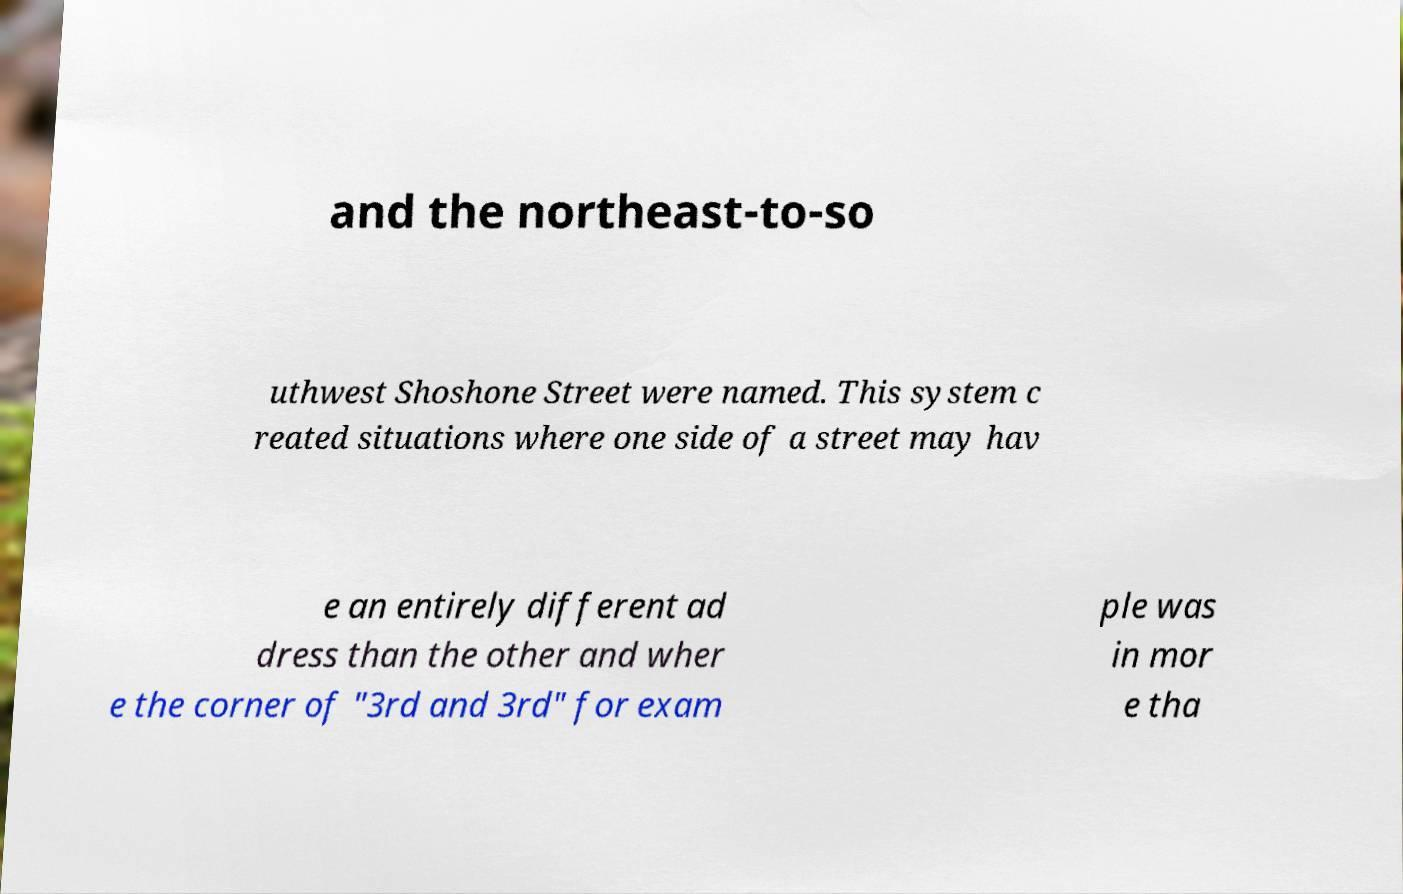What messages or text are displayed in this image? I need them in a readable, typed format. and the northeast-to-so uthwest Shoshone Street were named. This system c reated situations where one side of a street may hav e an entirely different ad dress than the other and wher e the corner of "3rd and 3rd" for exam ple was in mor e tha 